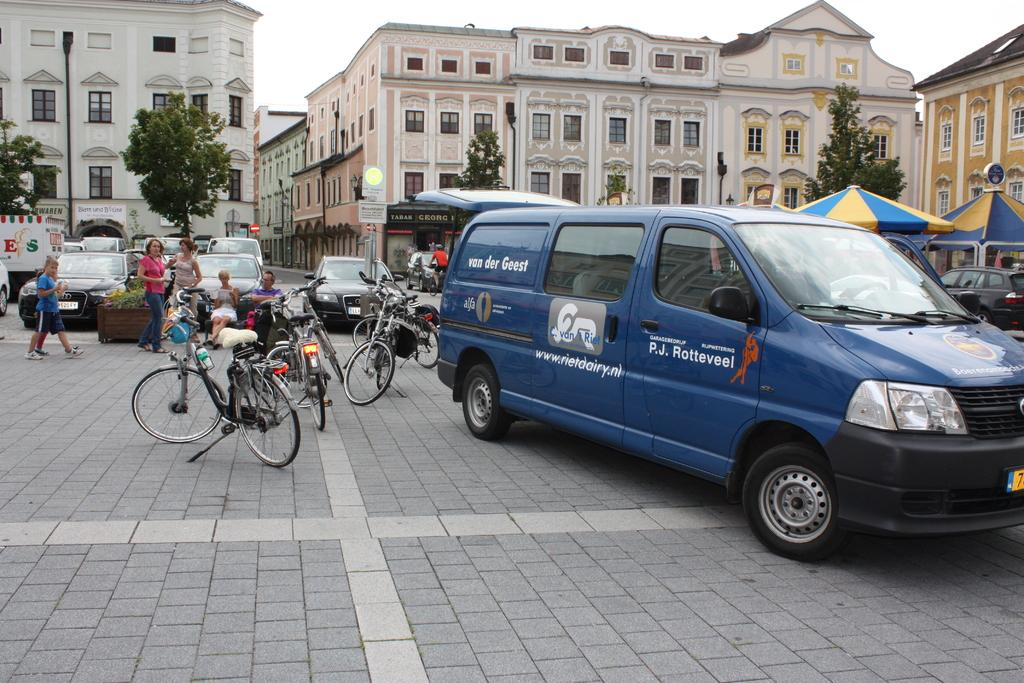<image>
Offer a succinct explanation of the picture presented. Van der Geest is the name branded on the work van. 